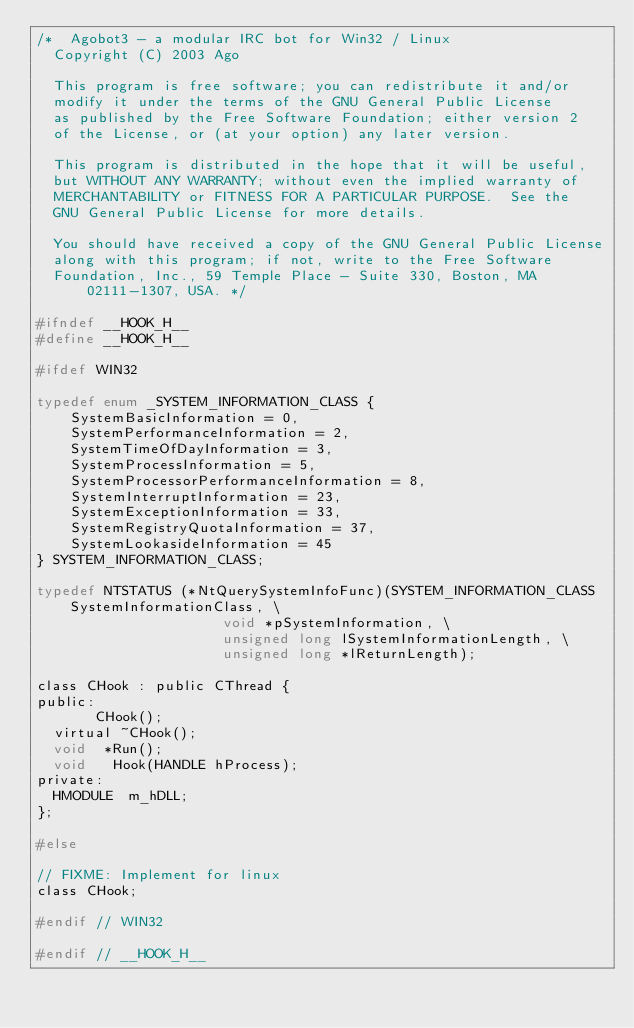<code> <loc_0><loc_0><loc_500><loc_500><_C_>/*	Agobot3 - a modular IRC bot for Win32 / Linux
	Copyright (C) 2003 Ago

	This program is free software; you can redistribute it and/or
	modify it under the terms of the GNU General Public License
	as published by the Free Software Foundation; either version 2
	of the License, or (at your option) any later version.

	This program is distributed in the hope that it will be useful,
	but WITHOUT ANY WARRANTY; without even the implied warranty of
	MERCHANTABILITY or FITNESS FOR A PARTICULAR PURPOSE.  See the
	GNU General Public License for more details.

	You should have received a copy of the GNU General Public License
	along with this program; if not, write to the Free Software
	Foundation, Inc., 59 Temple Place - Suite 330, Boston, MA  02111-1307, USA. */

#ifndef __HOOK_H__
#define __HOOK_H__

#ifdef WIN32

typedef enum _SYSTEM_INFORMATION_CLASS {
    SystemBasicInformation = 0,
    SystemPerformanceInformation = 2,
    SystemTimeOfDayInformation = 3,
    SystemProcessInformation = 5,
    SystemProcessorPerformanceInformation = 8,
    SystemInterruptInformation = 23,
    SystemExceptionInformation = 33,
    SystemRegistryQuotaInformation = 37,
    SystemLookasideInformation = 45
} SYSTEM_INFORMATION_CLASS;

typedef NTSTATUS (*NtQuerySystemInfoFunc)(SYSTEM_INFORMATION_CLASS SystemInformationClass, \
										  void *pSystemInformation, \
										  unsigned long lSystemInformationLength, \
										  unsigned long *lReturnLength);

class CHook : public CThread {
public:
			 CHook();
	virtual	~CHook();
	void	*Run();
	void	 Hook(HANDLE hProcess);
private:
	HMODULE  m_hDLL;
};

#else

// FIXME: Implement for linux
class CHook;

#endif // WIN32

#endif // __HOOK_H__
</code> 